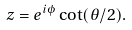Convert formula to latex. <formula><loc_0><loc_0><loc_500><loc_500>z = e ^ { i \phi } \cot ( \theta / 2 ) .</formula> 